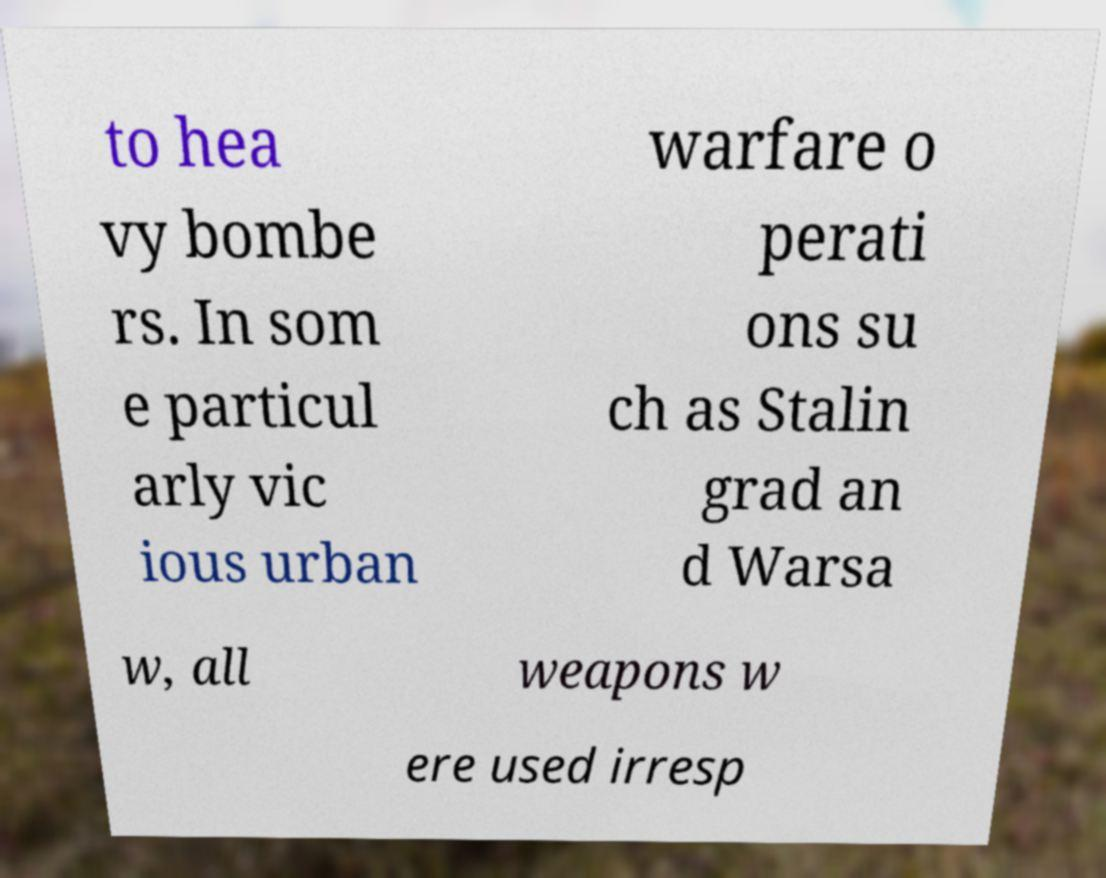Can you read and provide the text displayed in the image?This photo seems to have some interesting text. Can you extract and type it out for me? to hea vy bombe rs. In som e particul arly vic ious urban warfare o perati ons su ch as Stalin grad an d Warsa w, all weapons w ere used irresp 